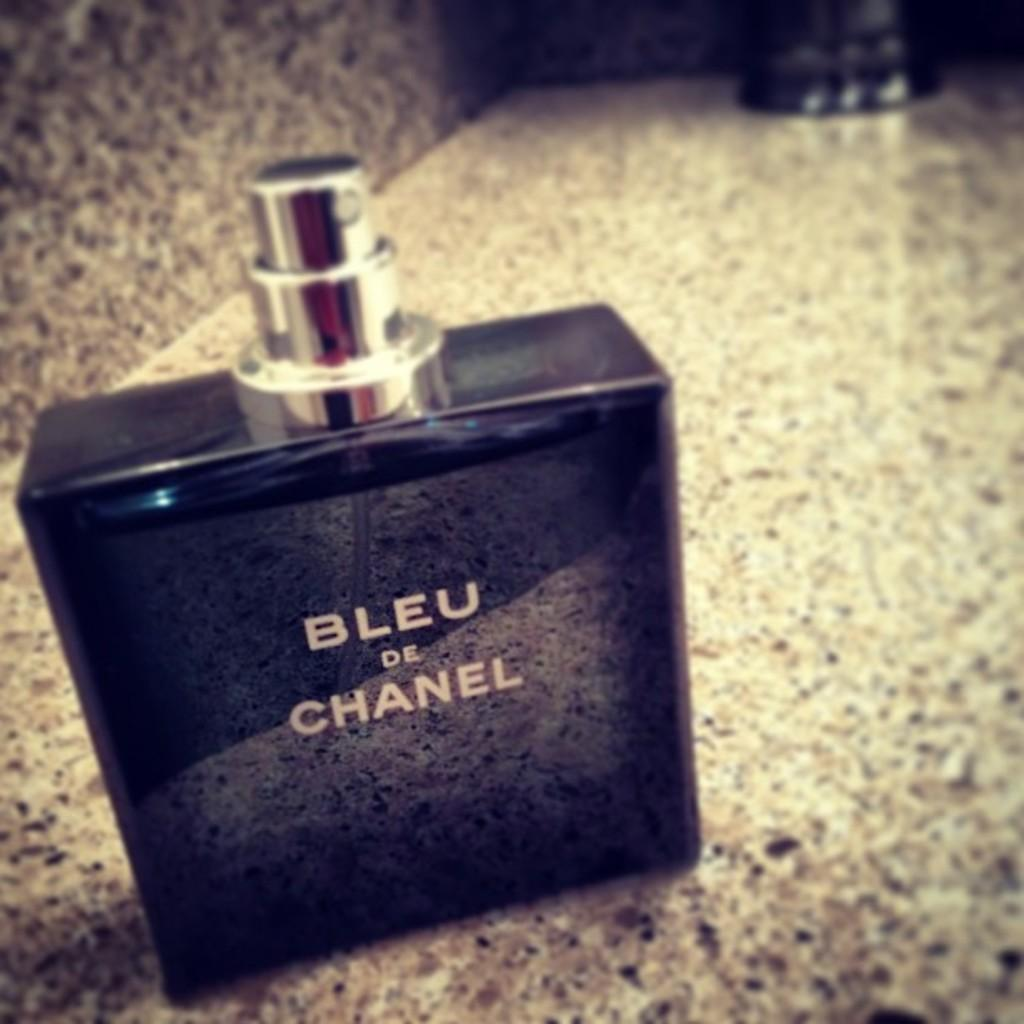What is the main object in the image? There is a perfume bottle in the image. Where is the perfume bottle located in relation to the rest of the image? The perfume bottle is in the foreground of the image. On what surface is the perfume bottle placed? The perfume bottle is on a surface. What type of noise does the goat make in the image? There is no goat present in the image, so it is not possible to determine the type of noise it might make. 